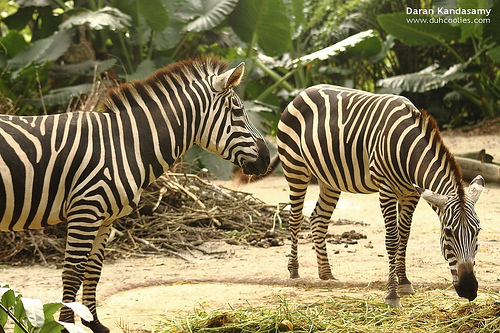Please extract the text content from this image. Daran Kandasamy WWW.duhcoolies.com 